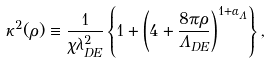Convert formula to latex. <formula><loc_0><loc_0><loc_500><loc_500>\kappa ^ { 2 } ( \rho ) \equiv \frac { 1 } { \chi \lambda _ { D E } ^ { 2 } } \left \{ 1 + \left ( 4 + \frac { 8 \pi \rho } { \Lambda _ { D E } } \right ) ^ { 1 + { \alpha _ { \Lambda } } } \right \} ,</formula> 